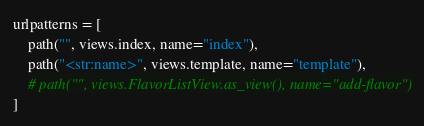<code> <loc_0><loc_0><loc_500><loc_500><_Python_>urlpatterns = [
    path("", views.index, name="index"),
    path("<str:name>", views.template, name="template"),
    # path("", views.FlavorListView.as_view(), name="add-flavor")
]
</code> 